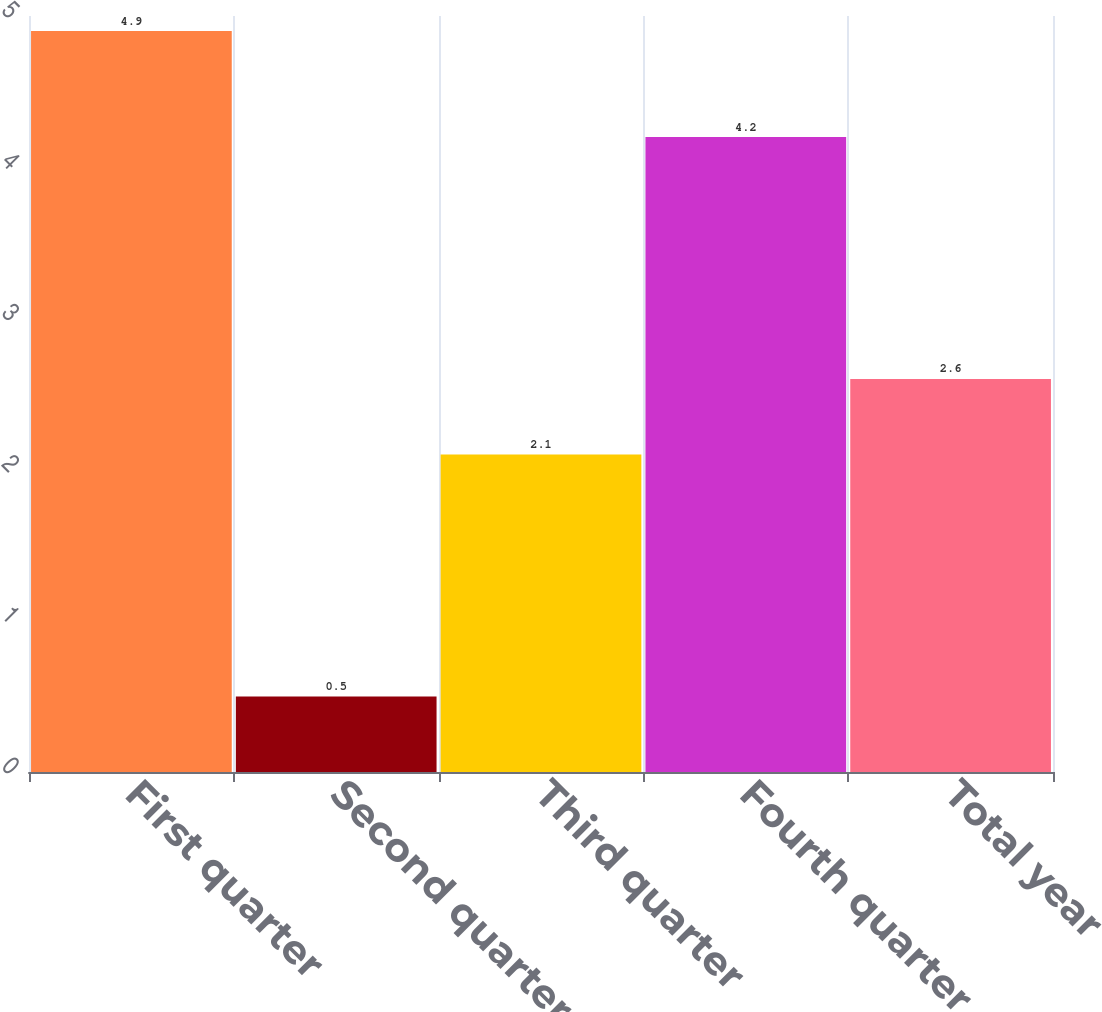Convert chart. <chart><loc_0><loc_0><loc_500><loc_500><bar_chart><fcel>First quarter<fcel>Second quarter<fcel>Third quarter<fcel>Fourth quarter<fcel>Total year<nl><fcel>4.9<fcel>0.5<fcel>2.1<fcel>4.2<fcel>2.6<nl></chart> 